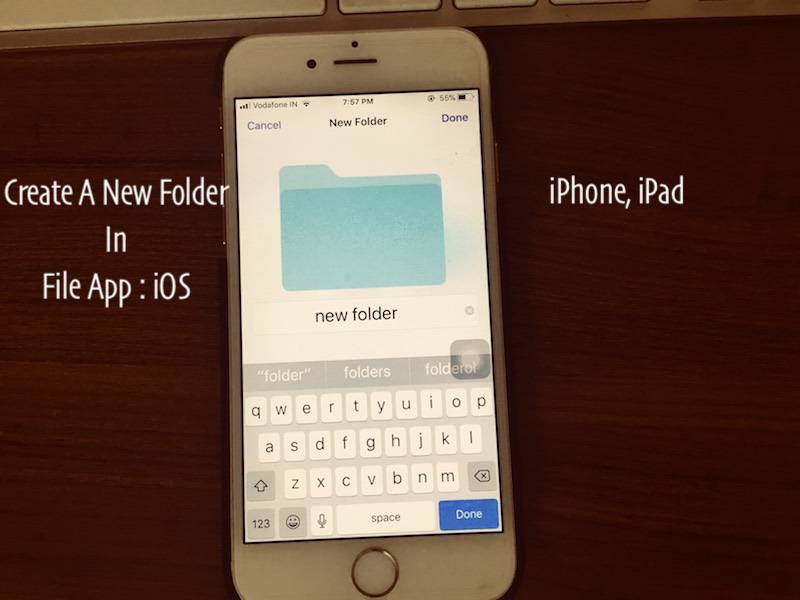What potential tasks could the user perform next given the current app and the device's general setup? After creating the new folder, the user has several potential tasks they could pursue. They might continue organizing and categorizing their files to maintain better order on their device. Additionally, they could begin to transfer or back up files to a cloud service to free up space. If they are preparing for the next day, they might also prioritize reviewing and organizing documents, setting reminders, or checking notifications. Given the time, there's a possibility they might also wind down their activities for the night and proceed to charge the device. 